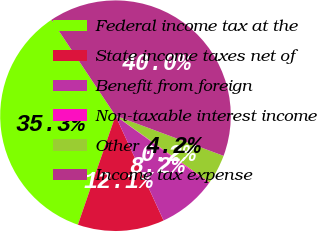<chart> <loc_0><loc_0><loc_500><loc_500><pie_chart><fcel>Federal income tax at the<fcel>State income taxes net of<fcel>Benefit from foreign<fcel>Non-taxable interest income<fcel>Other<fcel>Income tax expense<nl><fcel>35.34%<fcel>12.13%<fcel>8.15%<fcel>0.18%<fcel>4.16%<fcel>40.03%<nl></chart> 